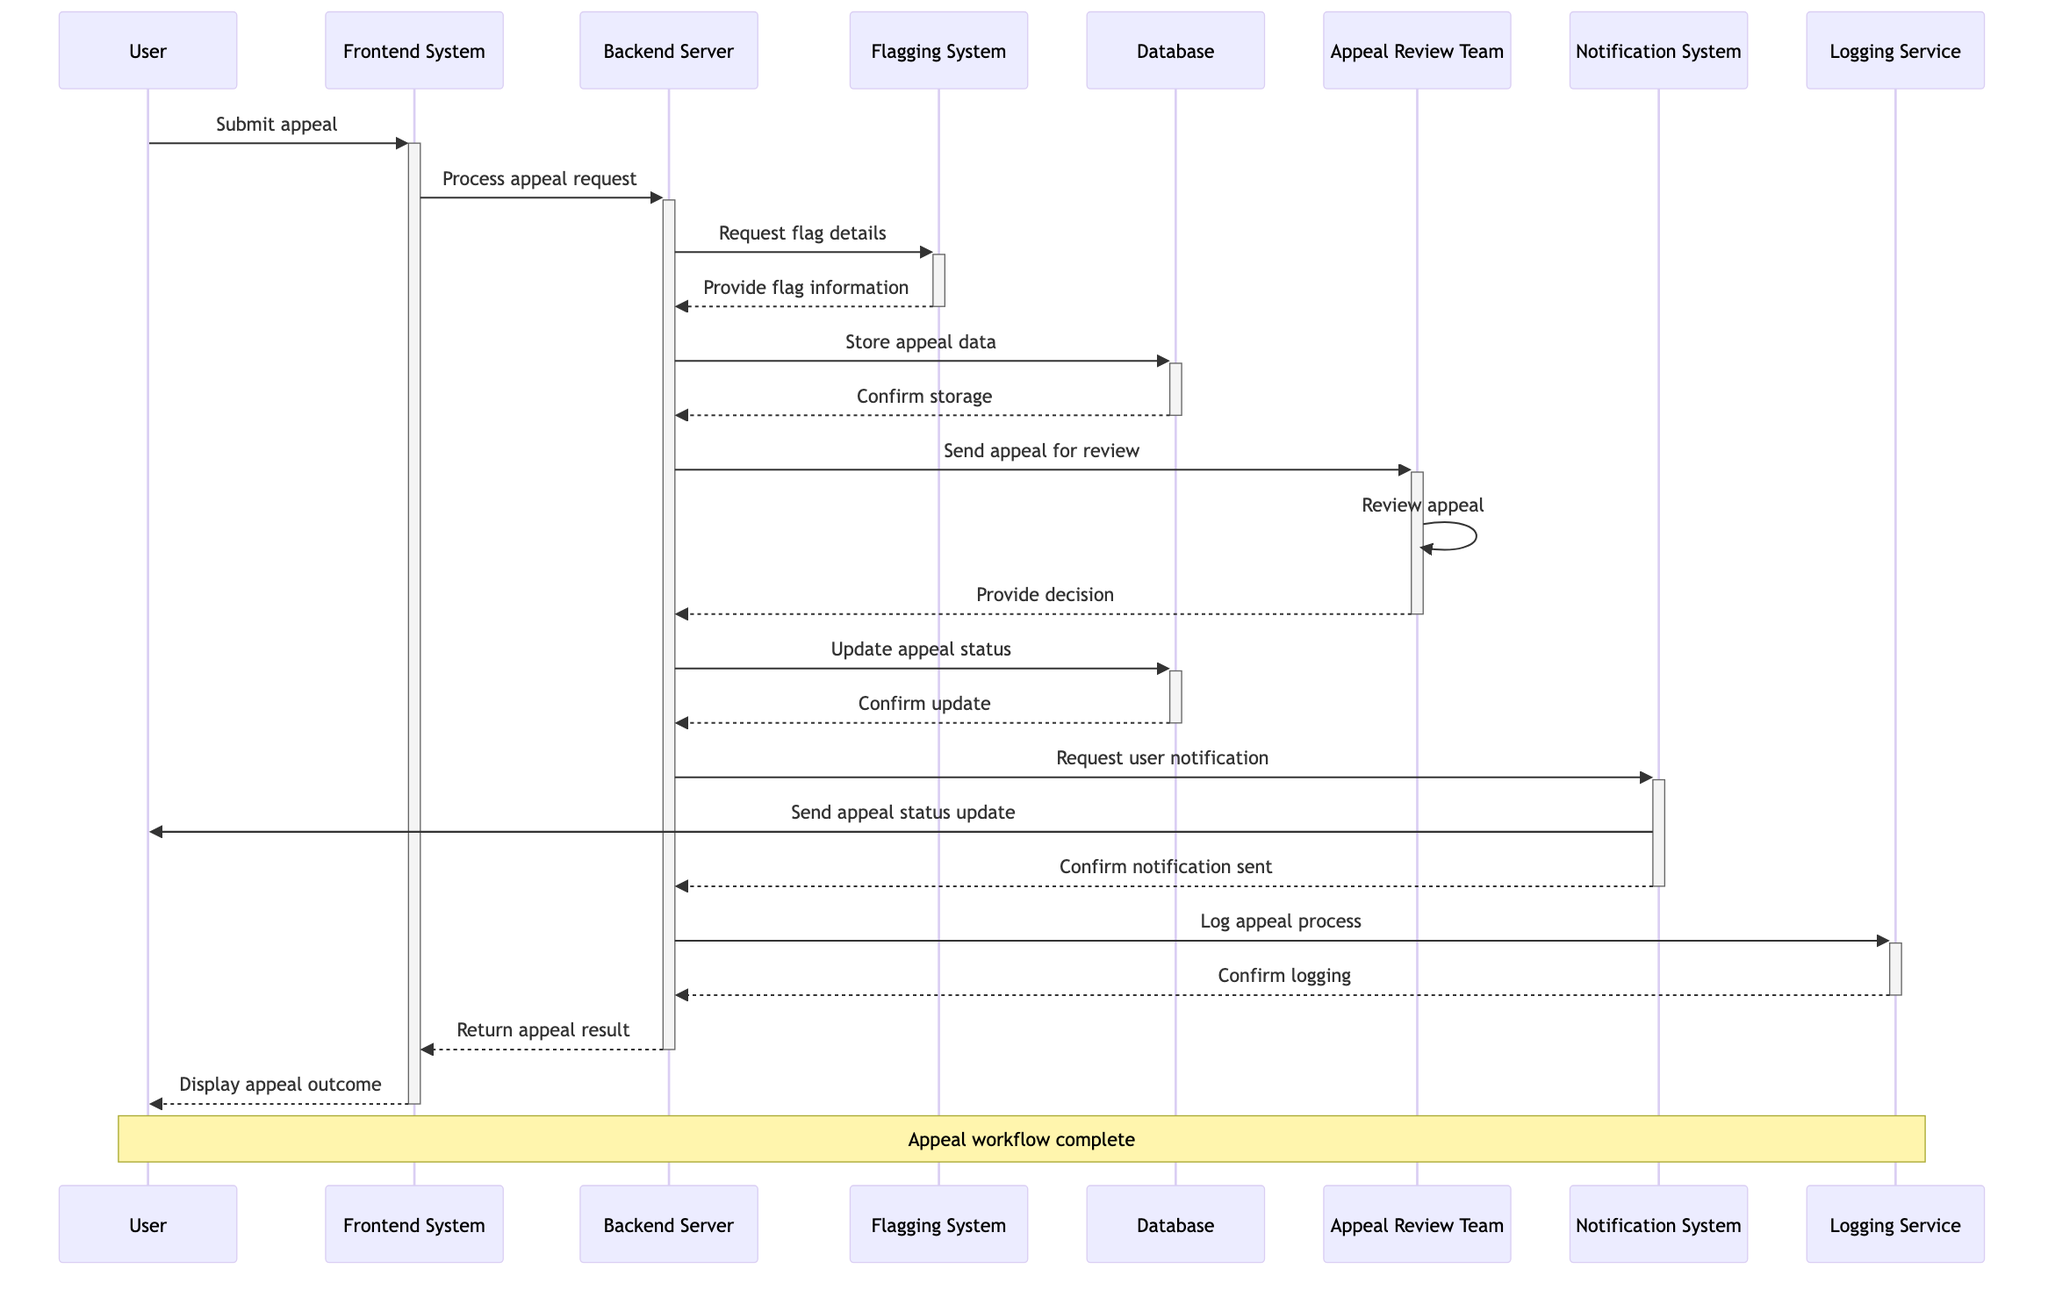What is the first action taken by the user? The user submits an appeal, which is the first action represented in the diagram.
Answer: Submit appeal How many participants are involved in the workflow? The diagram includes seven participants: User, Frontend System, Backend Server, Flagging System, Appeal Review Team, Notification System, and Logging Service.
Answer: Seven participants What does the Backend Server request after processing the appeal request? The Backend Server requests flag details from the Flagging System right after processing the appeal request.
Answer: Request flag details Which system confirms the storage of appeal data? The Database confirms the storage of appeal data after the Backend Server stores it.
Answer: Database How many times does the Notification System interact with the Backend Server? The Notification System interacts with the Backend Server twice: once to send the appeal status update and again to confirm that notification was sent.
Answer: Twice What is the purpose of the Logging Service in the workflow? The Logging Service logs the entire appeal process for auditing and debugging purposes, which is crucial for tracking and recording actions.
Answer: Log appeal process Who reviews the user’s appeal? The Appeal Review Team is responsible for reviewing the user's appeal as indicated in the diagram.
Answer: Appeal Review Team What happens after the Appeal Review Team provides a decision? After the Appeal Review Team provides a decision, the Backend Server updates the appeal status in the Database.
Answer: Update appeal status What type of workflow is represented in the diagram? The diagram represents a user appeal workflow after a flag has been imposed, showing the steps taken from appeal submission to outcome notification.
Answer: User appeal workflow 